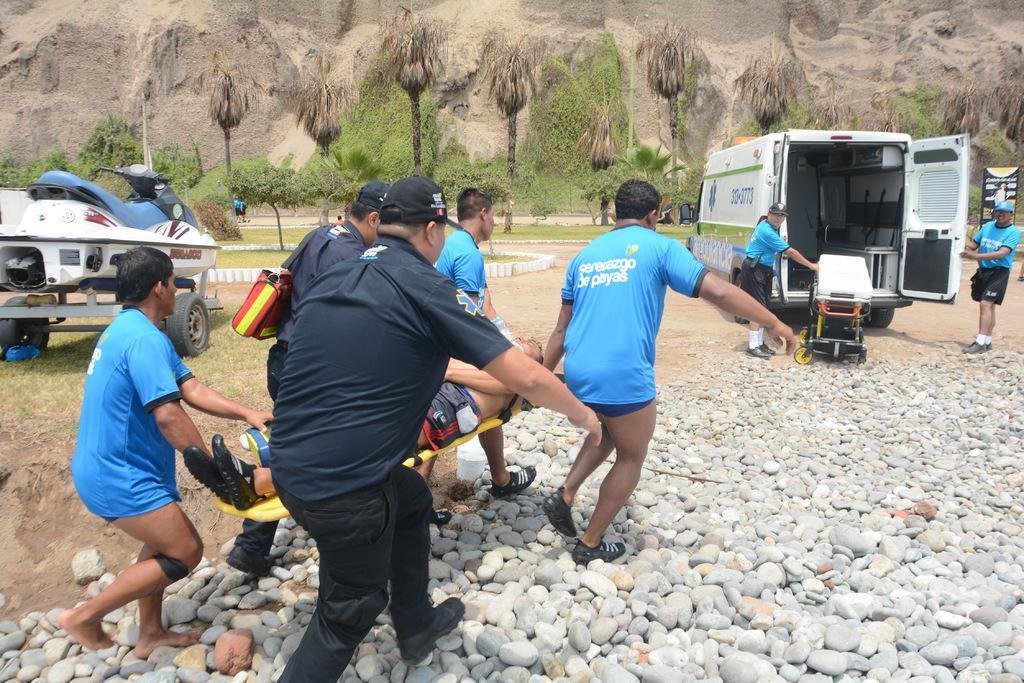Could you give a brief overview of what you see in this image? In this image I can see group of people walking and the person in front is wearing blue color dress. Background I can see few vehicles, trees in green color and I can also see a black color board attached to the pole and I can also see few stones. 